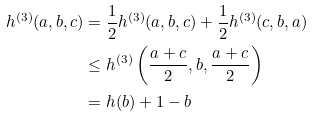Convert formula to latex. <formula><loc_0><loc_0><loc_500><loc_500>h ^ { ( 3 ) } ( a , b , c ) & = \frac { 1 } { 2 } h ^ { ( 3 ) } ( a , b , c ) + \frac { 1 } { 2 } h ^ { ( 3 ) } ( c , b , a ) \\ & \leq h ^ { ( 3 ) } \left ( \frac { a + c } { 2 } , b , \frac { a + c } { 2 } \right ) \\ & = h ( b ) + 1 - b</formula> 